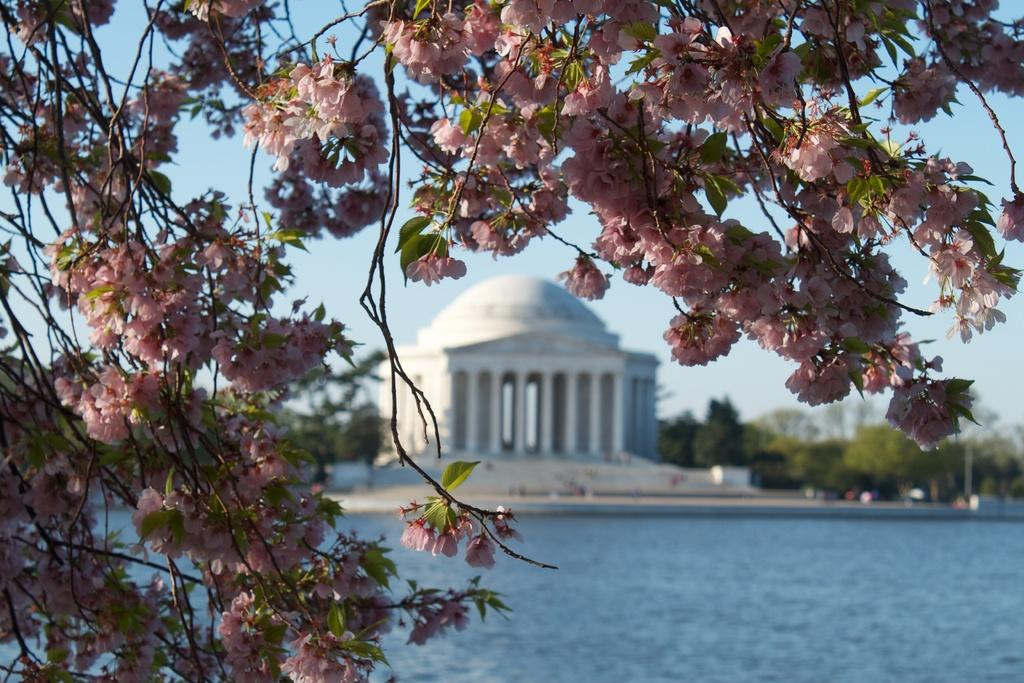What type of plants can be seen in the image? There are flowers in the image. What is visible at the bottom of the image? There is water visible at the bottom of the image. What can be seen in the background of the image? There are trees and a building in the background of the image. What is visible at the top of the image? The sky is visible at the top of the image. Can you see a list of animals on display at the zoo in the image? There is no zoo or list of animals present in the image; it features flowers, water, trees, a building, and the sky. 